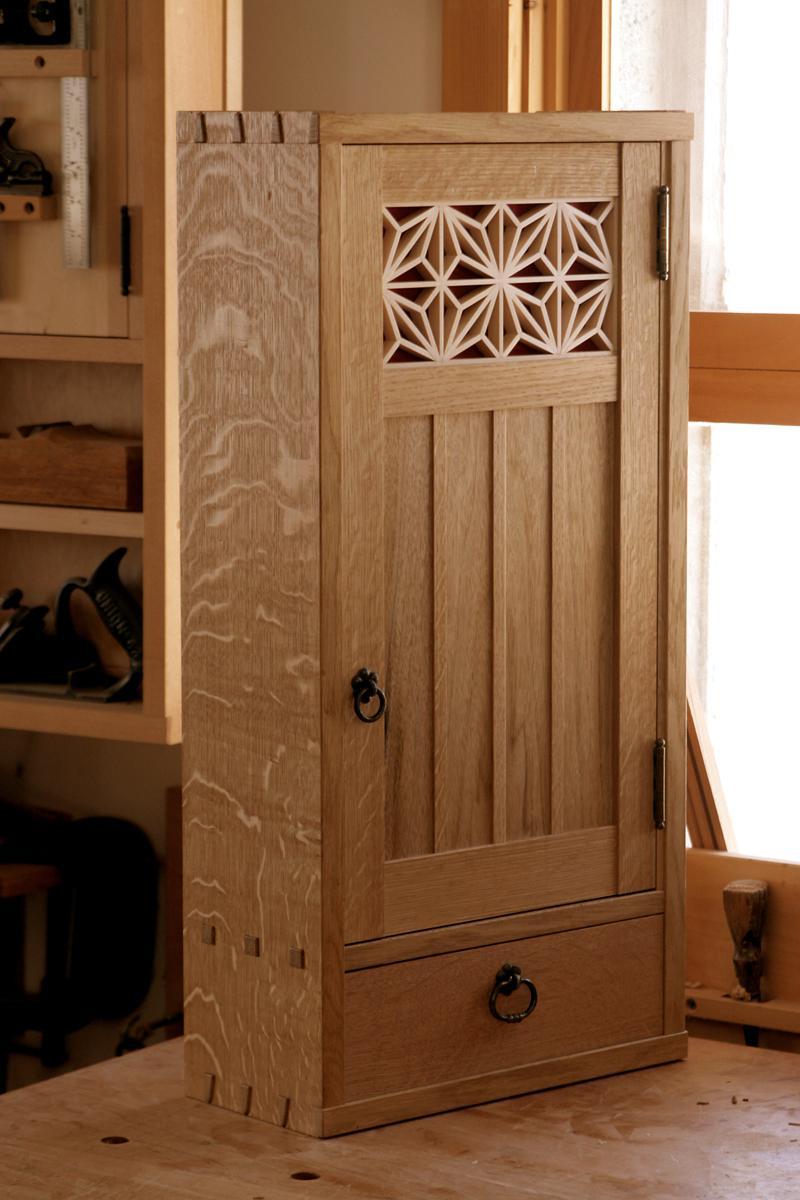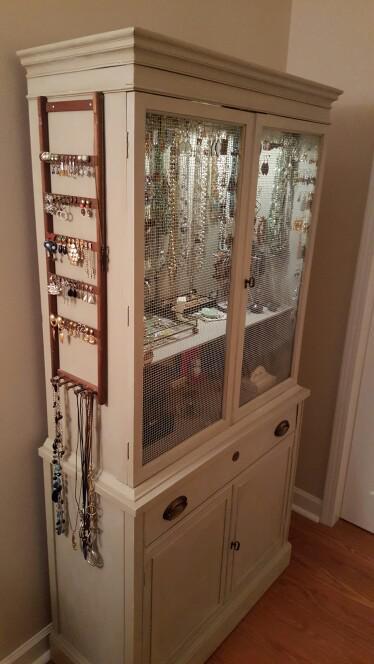The first image is the image on the left, the second image is the image on the right. Examine the images to the left and right. Is the description "A flat-topped cabinet includes bright yellow on at least some surface." accurate? Answer yes or no. No. 